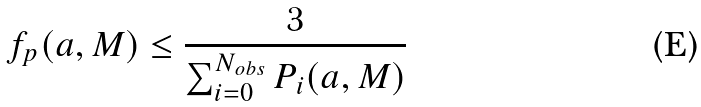Convert formula to latex. <formula><loc_0><loc_0><loc_500><loc_500>f _ { p } ( a , M ) \leq \frac { 3 } { \sum ^ { N _ { o b s } } _ { i = 0 } P _ { i } ( a , M ) }</formula> 